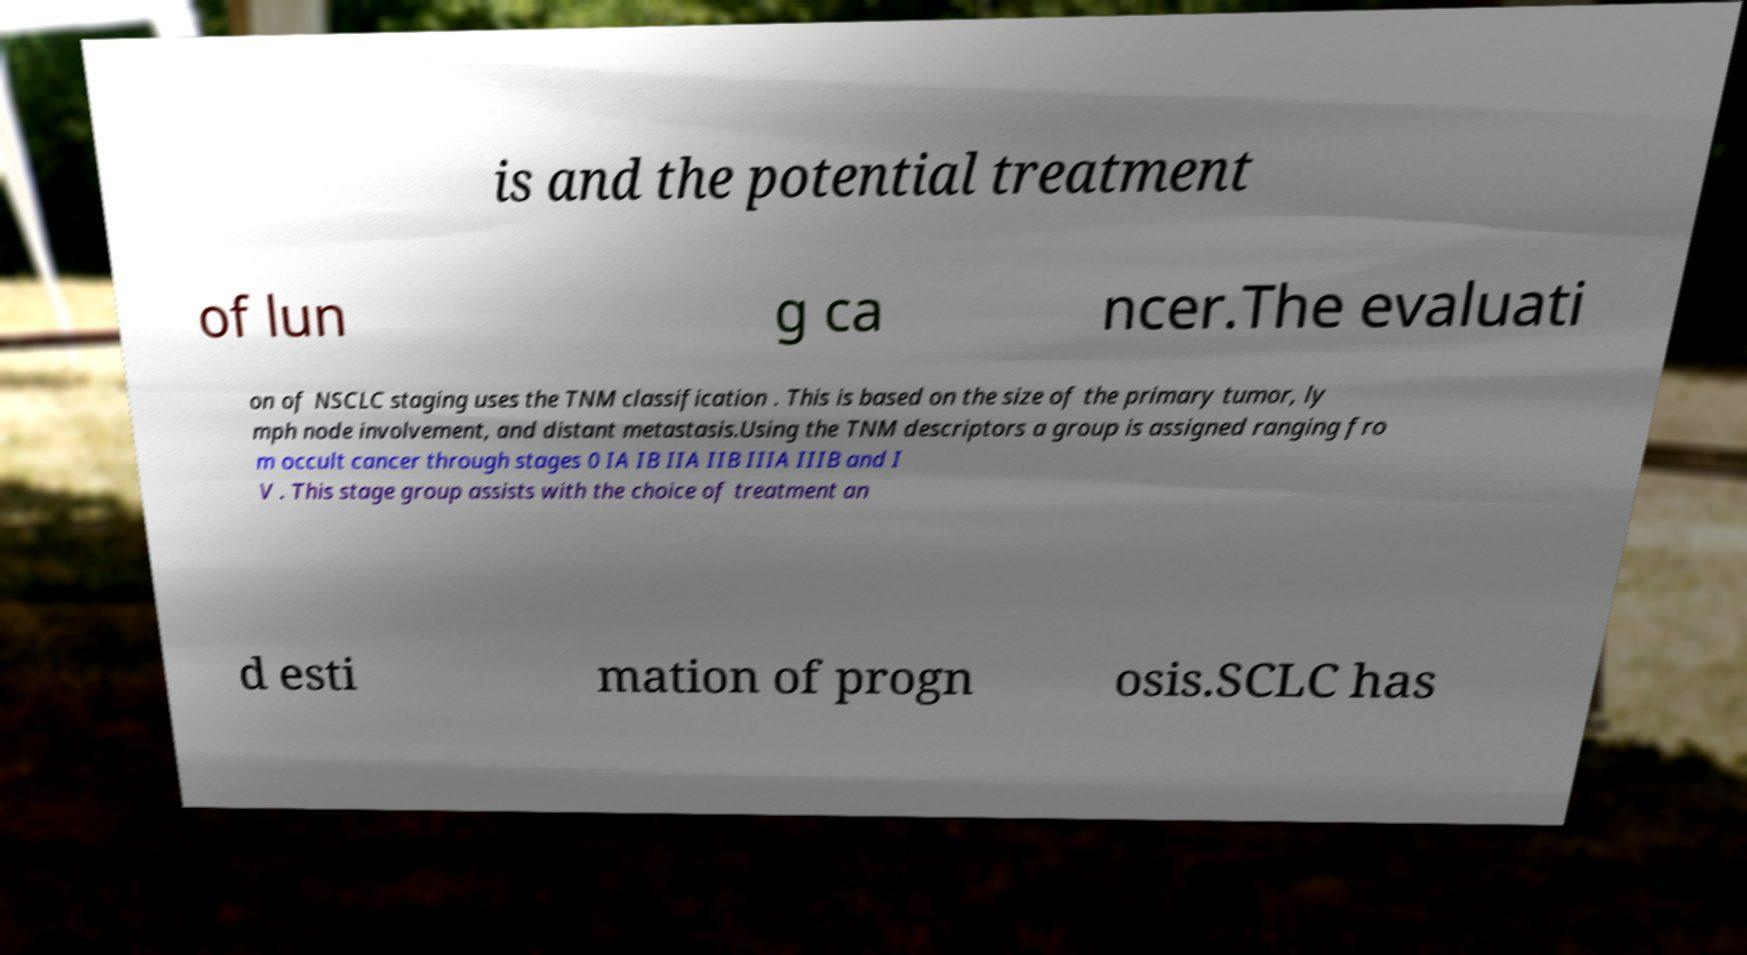Please identify and transcribe the text found in this image. is and the potential treatment of lun g ca ncer.The evaluati on of NSCLC staging uses the TNM classification . This is based on the size of the primary tumor, ly mph node involvement, and distant metastasis.Using the TNM descriptors a group is assigned ranging fro m occult cancer through stages 0 IA IB IIA IIB IIIA IIIB and I V . This stage group assists with the choice of treatment an d esti mation of progn osis.SCLC has 